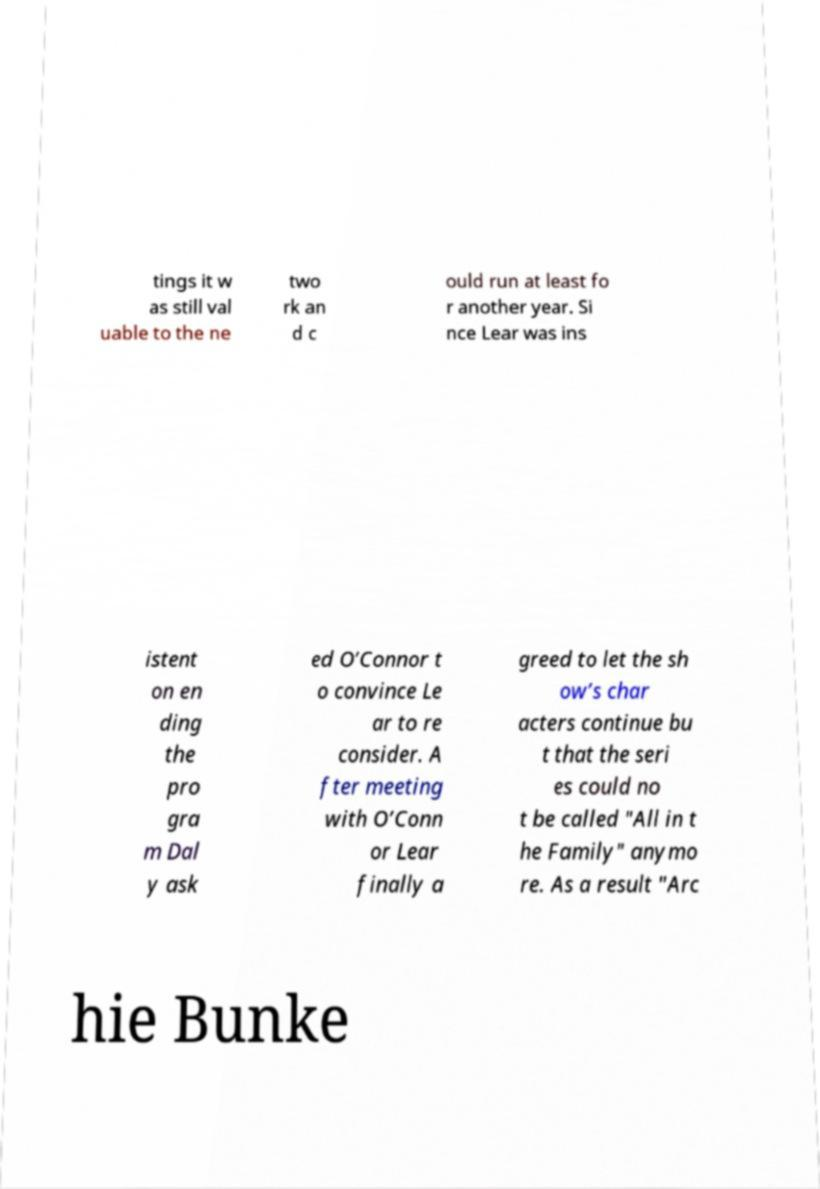Could you extract and type out the text from this image? tings it w as still val uable to the ne two rk an d c ould run at least fo r another year. Si nce Lear was ins istent on en ding the pro gra m Dal y ask ed O’Connor t o convince Le ar to re consider. A fter meeting with O’Conn or Lear finally a greed to let the sh ow’s char acters continue bu t that the seri es could no t be called "All in t he Family" anymo re. As a result "Arc hie Bunke 